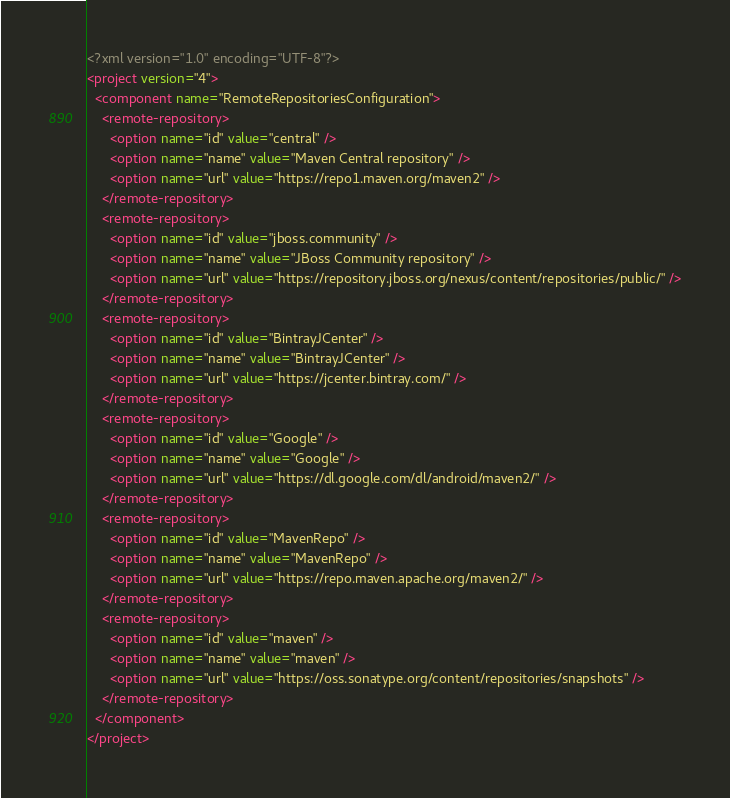Convert code to text. <code><loc_0><loc_0><loc_500><loc_500><_XML_><?xml version="1.0" encoding="UTF-8"?>
<project version="4">
  <component name="RemoteRepositoriesConfiguration">
    <remote-repository>
      <option name="id" value="central" />
      <option name="name" value="Maven Central repository" />
      <option name="url" value="https://repo1.maven.org/maven2" />
    </remote-repository>
    <remote-repository>
      <option name="id" value="jboss.community" />
      <option name="name" value="JBoss Community repository" />
      <option name="url" value="https://repository.jboss.org/nexus/content/repositories/public/" />
    </remote-repository>
    <remote-repository>
      <option name="id" value="BintrayJCenter" />
      <option name="name" value="BintrayJCenter" />
      <option name="url" value="https://jcenter.bintray.com/" />
    </remote-repository>
    <remote-repository>
      <option name="id" value="Google" />
      <option name="name" value="Google" />
      <option name="url" value="https://dl.google.com/dl/android/maven2/" />
    </remote-repository>
    <remote-repository>
      <option name="id" value="MavenRepo" />
      <option name="name" value="MavenRepo" />
      <option name="url" value="https://repo.maven.apache.org/maven2/" />
    </remote-repository>
    <remote-repository>
      <option name="id" value="maven" />
      <option name="name" value="maven" />
      <option name="url" value="https://oss.sonatype.org/content/repositories/snapshots" />
    </remote-repository>
  </component>
</project></code> 